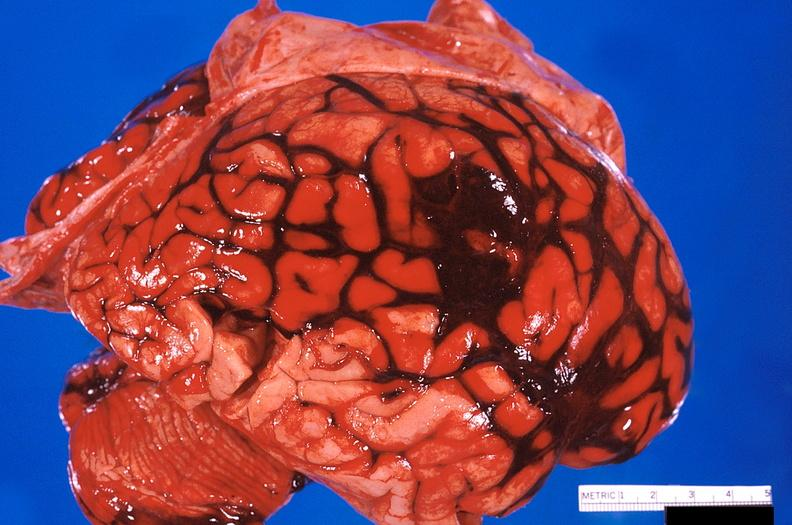what does this image show?
Answer the question using a single word or phrase. Brain 